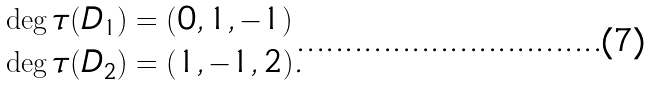Convert formula to latex. <formula><loc_0><loc_0><loc_500><loc_500>\deg \tau ( D _ { 1 } ) & = ( 0 , 1 , - 1 ) \\ \deg \tau ( D _ { 2 } ) & = ( 1 , - 1 , 2 ) .</formula> 